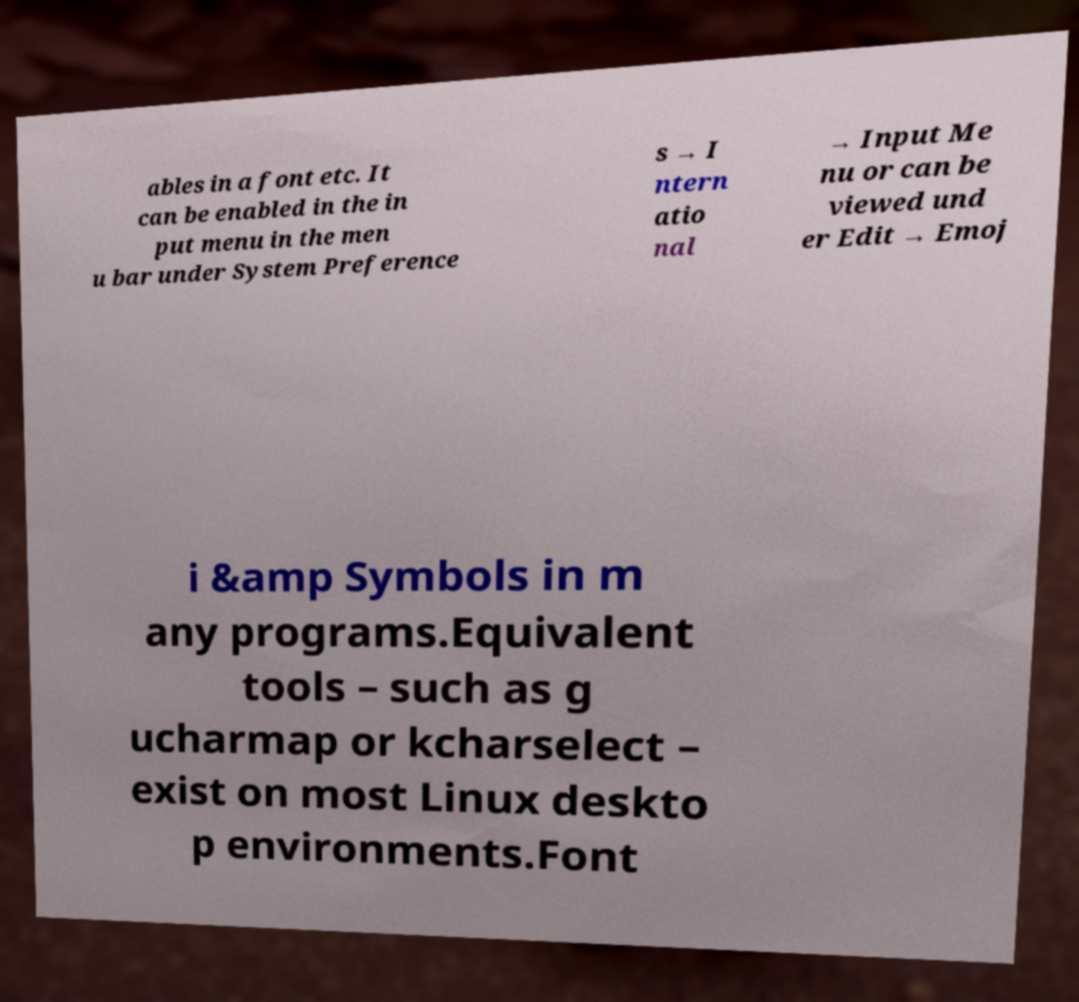Could you assist in decoding the text presented in this image and type it out clearly? ables in a font etc. It can be enabled in the in put menu in the men u bar under System Preference s → I ntern atio nal → Input Me nu or can be viewed und er Edit → Emoj i &amp Symbols in m any programs.Equivalent tools – such as g ucharmap or kcharselect – exist on most Linux deskto p environments.Font 